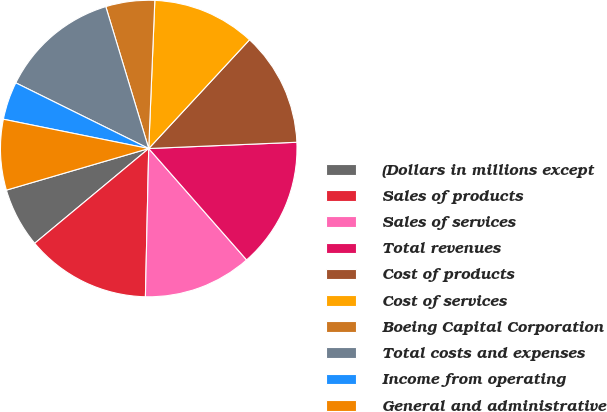Convert chart to OTSL. <chart><loc_0><loc_0><loc_500><loc_500><pie_chart><fcel>(Dollars in millions except<fcel>Sales of products<fcel>Sales of services<fcel>Total revenues<fcel>Cost of products<fcel>Cost of services<fcel>Boeing Capital Corporation<fcel>Total costs and expenses<fcel>Income from operating<fcel>General and administrative<nl><fcel>6.51%<fcel>13.61%<fcel>11.83%<fcel>14.2%<fcel>12.43%<fcel>11.24%<fcel>5.33%<fcel>13.02%<fcel>4.14%<fcel>7.69%<nl></chart> 